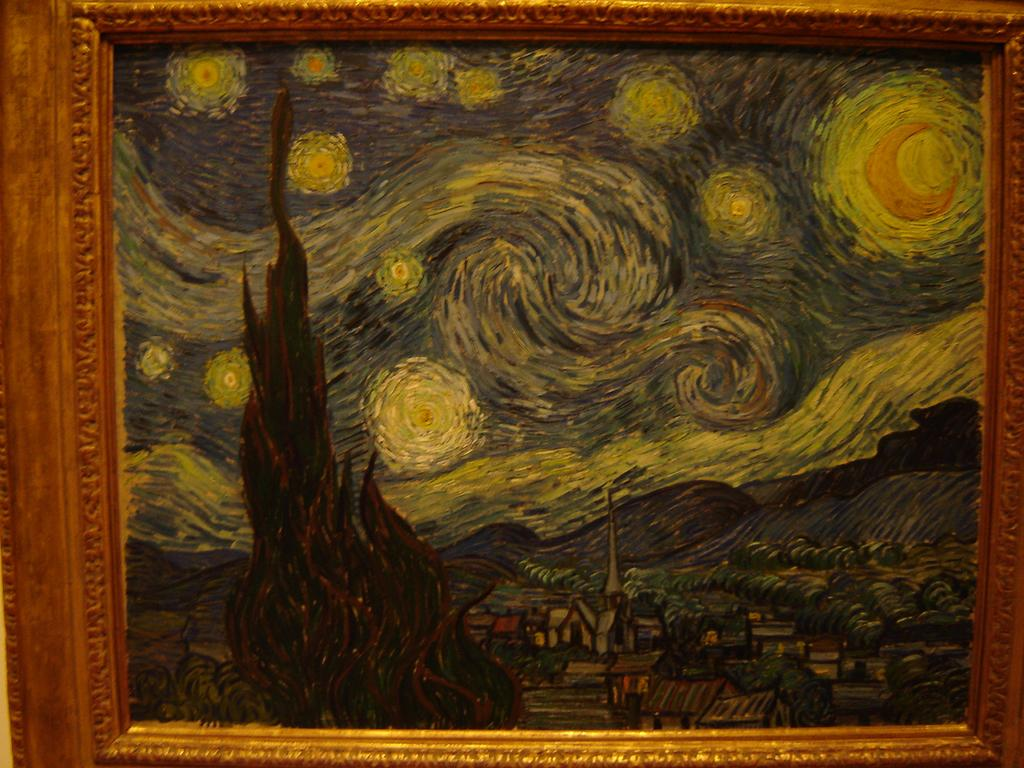What is the main object in the image? There is a frame in the image. What is displayed within the frame? There is a painting on the frame. How many babies are depicted in the painting within the frame? There is no information about babies or any other specific content within the painting, as the facts only mention the presence of a painting on the frame. 